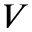Convert formula to latex. <formula><loc_0><loc_0><loc_500><loc_500>V</formula> 